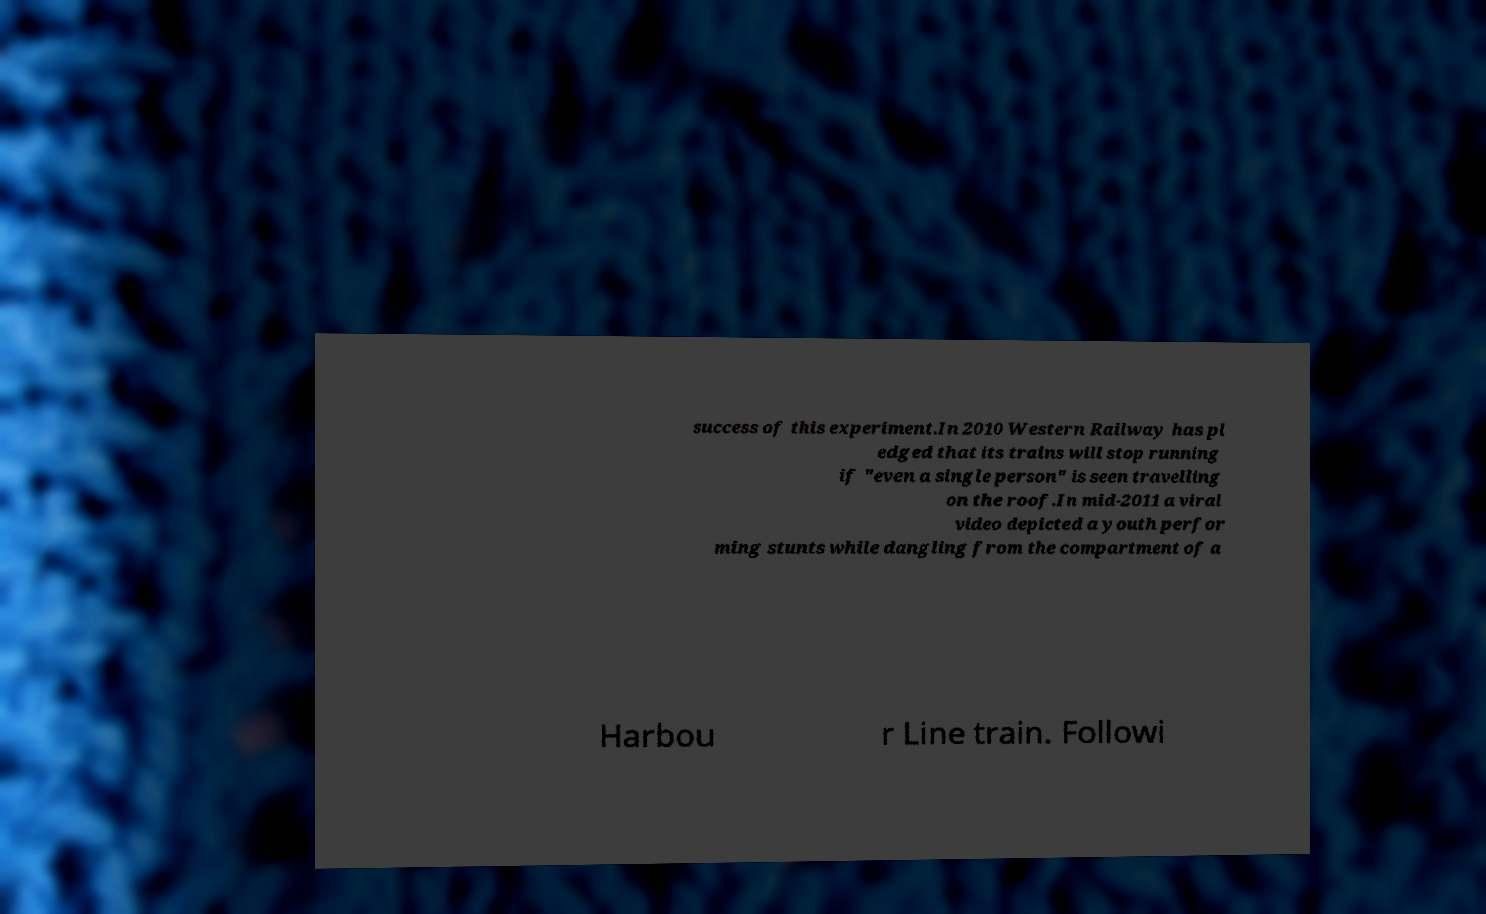What messages or text are displayed in this image? I need them in a readable, typed format. success of this experiment.In 2010 Western Railway has pl edged that its trains will stop running if "even a single person" is seen travelling on the roof.In mid-2011 a viral video depicted a youth perfor ming stunts while dangling from the compartment of a Harbou r Line train. Followi 